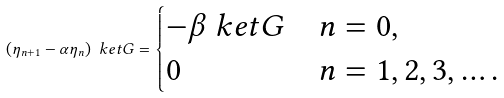Convert formula to latex. <formula><loc_0><loc_0><loc_500><loc_500>( \eta _ { n + 1 } - \alpha \eta _ { n } ) \ k e t { G } = \begin{cases} - \beta \ k e t { G } & n = 0 , \\ 0 & n = 1 , 2 , 3 , \dots . \end{cases}</formula> 